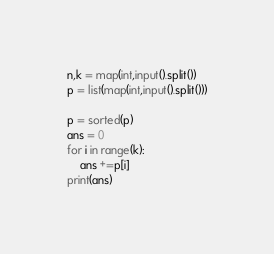Convert code to text. <code><loc_0><loc_0><loc_500><loc_500><_Python_>n,k = map(int,input().split())
p = list(map(int,input().split()))

p = sorted(p)
ans = 0
for i in range(k):
    ans +=p[i]
print(ans)</code> 